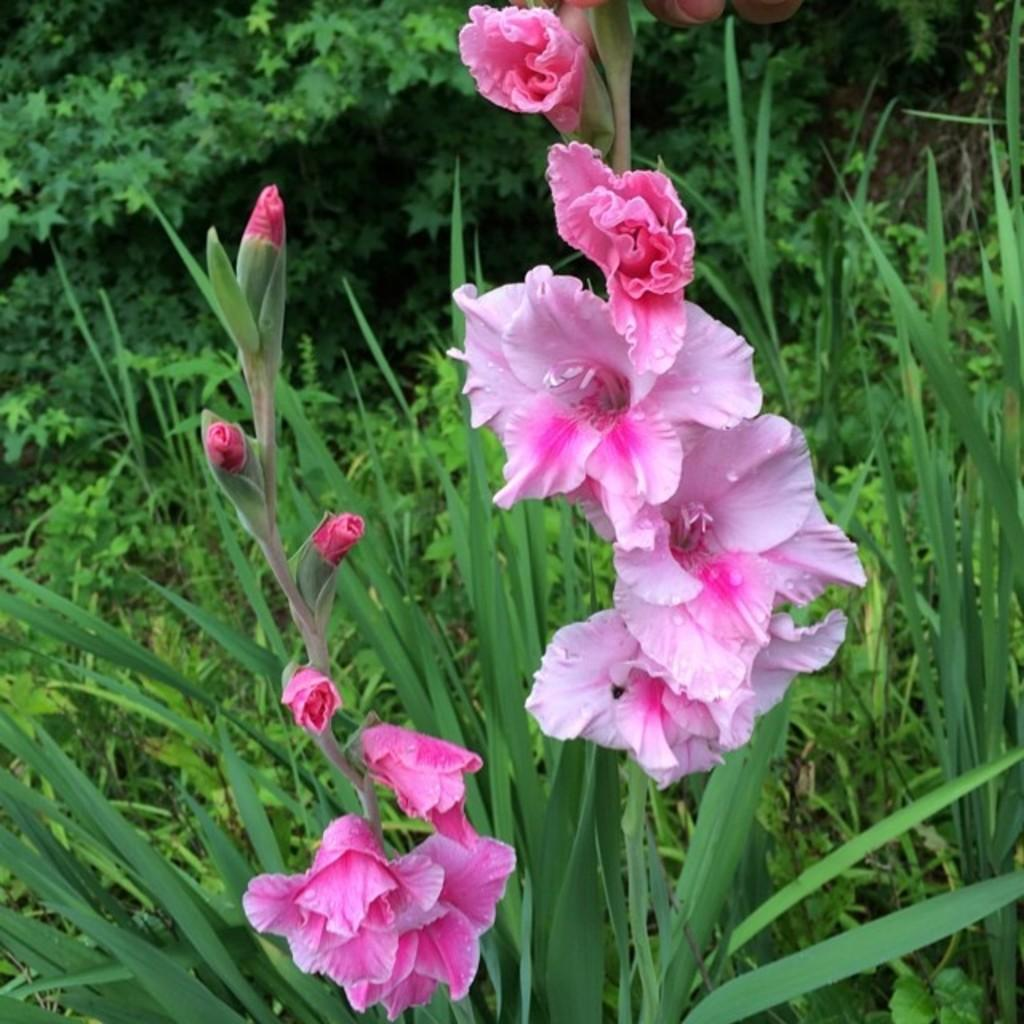What is located in the middle of the image? There are flowers in the middle of the image. What is present behind the flowers? There are plants behind the flowers. What is located behind the plants? There are trees behind the plants. What can be seen at the top of the image? There are fingers visible at the top of the image. What shape is the skate that the sister is riding in the image? There is no skate or sister present in the image; it only features flowers, plants, trees, and fingers. 